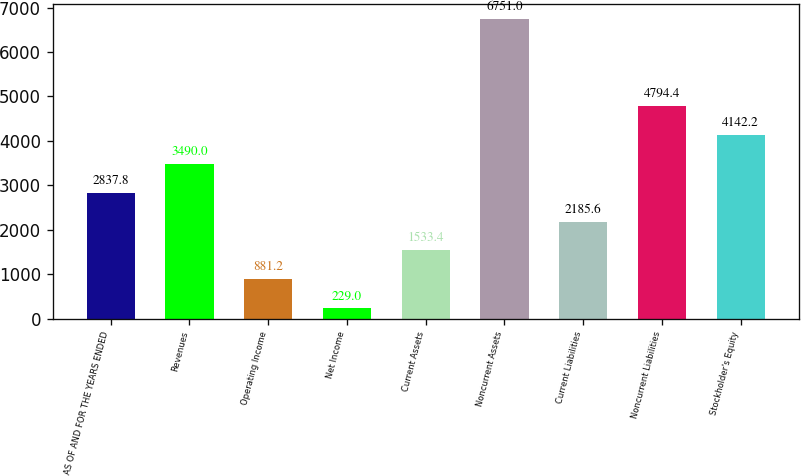<chart> <loc_0><loc_0><loc_500><loc_500><bar_chart><fcel>AS OF AND FOR THE YEARS ENDED<fcel>Revenues<fcel>Operating Income<fcel>Net Income<fcel>Current Assets<fcel>Noncurrent Assets<fcel>Current Liabilities<fcel>Noncurrent Liabilities<fcel>Stockholder's Equity<nl><fcel>2837.8<fcel>3490<fcel>881.2<fcel>229<fcel>1533.4<fcel>6751<fcel>2185.6<fcel>4794.4<fcel>4142.2<nl></chart> 